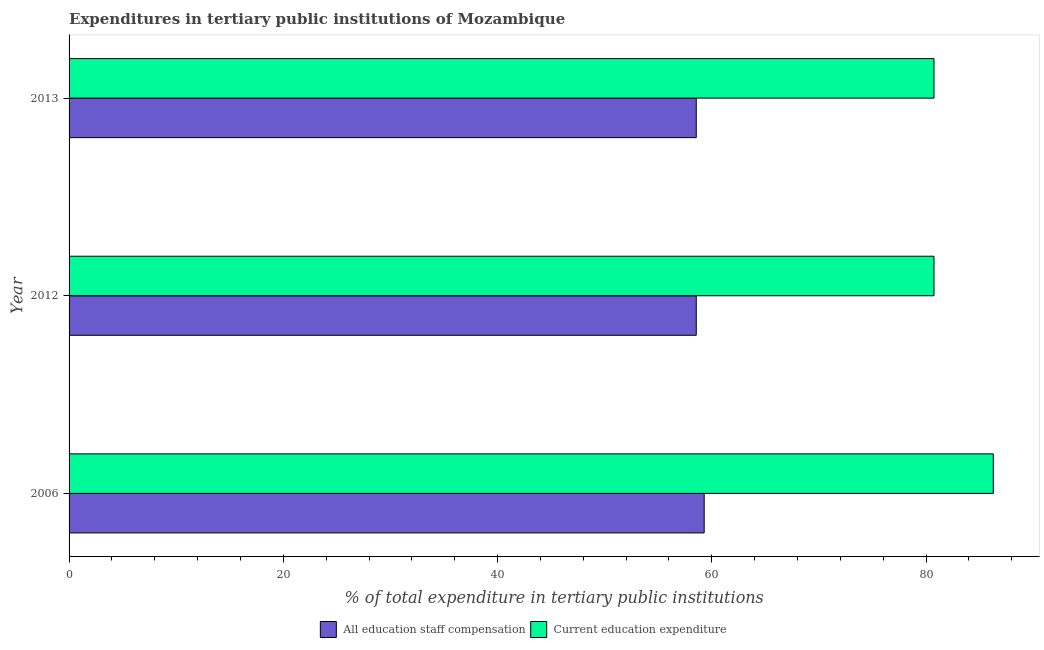How many groups of bars are there?
Your response must be concise. 3. Are the number of bars per tick equal to the number of legend labels?
Your response must be concise. Yes. Are the number of bars on each tick of the Y-axis equal?
Give a very brief answer. Yes. How many bars are there on the 1st tick from the top?
Offer a very short reply. 2. How many bars are there on the 3rd tick from the bottom?
Make the answer very short. 2. What is the expenditure in education in 2013?
Ensure brevity in your answer.  80.74. Across all years, what is the maximum expenditure in education?
Give a very brief answer. 86.28. Across all years, what is the minimum expenditure in education?
Your response must be concise. 80.74. In which year was the expenditure in education minimum?
Offer a very short reply. 2012. What is the total expenditure in education in the graph?
Your answer should be very brief. 247.76. What is the difference between the expenditure in education in 2006 and that in 2012?
Give a very brief answer. 5.53. What is the difference between the expenditure in staff compensation in 2013 and the expenditure in education in 2006?
Offer a very short reply. -27.73. What is the average expenditure in education per year?
Provide a succinct answer. 82.58. In the year 2012, what is the difference between the expenditure in staff compensation and expenditure in education?
Give a very brief answer. -22.19. In how many years, is the expenditure in education greater than 4 %?
Your answer should be compact. 3. What is the difference between the highest and the second highest expenditure in education?
Make the answer very short. 5.53. What is the difference between the highest and the lowest expenditure in education?
Make the answer very short. 5.53. What does the 2nd bar from the top in 2012 represents?
Your answer should be very brief. All education staff compensation. What does the 2nd bar from the bottom in 2012 represents?
Provide a short and direct response. Current education expenditure. How many years are there in the graph?
Provide a succinct answer. 3. Are the values on the major ticks of X-axis written in scientific E-notation?
Provide a succinct answer. No. Does the graph contain any zero values?
Your answer should be very brief. No. Does the graph contain grids?
Offer a terse response. No. Where does the legend appear in the graph?
Your answer should be very brief. Bottom center. How many legend labels are there?
Make the answer very short. 2. How are the legend labels stacked?
Your answer should be compact. Horizontal. What is the title of the graph?
Ensure brevity in your answer.  Expenditures in tertiary public institutions of Mozambique. Does "Underweight" appear as one of the legend labels in the graph?
Provide a succinct answer. No. What is the label or title of the X-axis?
Your answer should be compact. % of total expenditure in tertiary public institutions. What is the label or title of the Y-axis?
Offer a very short reply. Year. What is the % of total expenditure in tertiary public institutions of All education staff compensation in 2006?
Your response must be concise. 59.29. What is the % of total expenditure in tertiary public institutions in Current education expenditure in 2006?
Keep it short and to the point. 86.28. What is the % of total expenditure in tertiary public institutions in All education staff compensation in 2012?
Keep it short and to the point. 58.55. What is the % of total expenditure in tertiary public institutions in Current education expenditure in 2012?
Offer a very short reply. 80.74. What is the % of total expenditure in tertiary public institutions in All education staff compensation in 2013?
Offer a very short reply. 58.55. What is the % of total expenditure in tertiary public institutions in Current education expenditure in 2013?
Offer a terse response. 80.74. Across all years, what is the maximum % of total expenditure in tertiary public institutions of All education staff compensation?
Keep it short and to the point. 59.29. Across all years, what is the maximum % of total expenditure in tertiary public institutions in Current education expenditure?
Your response must be concise. 86.28. Across all years, what is the minimum % of total expenditure in tertiary public institutions of All education staff compensation?
Your answer should be compact. 58.55. Across all years, what is the minimum % of total expenditure in tertiary public institutions of Current education expenditure?
Provide a succinct answer. 80.74. What is the total % of total expenditure in tertiary public institutions in All education staff compensation in the graph?
Give a very brief answer. 176.38. What is the total % of total expenditure in tertiary public institutions of Current education expenditure in the graph?
Your response must be concise. 247.76. What is the difference between the % of total expenditure in tertiary public institutions in All education staff compensation in 2006 and that in 2012?
Offer a very short reply. 0.74. What is the difference between the % of total expenditure in tertiary public institutions in Current education expenditure in 2006 and that in 2012?
Ensure brevity in your answer.  5.53. What is the difference between the % of total expenditure in tertiary public institutions in All education staff compensation in 2006 and that in 2013?
Offer a terse response. 0.74. What is the difference between the % of total expenditure in tertiary public institutions of Current education expenditure in 2006 and that in 2013?
Your answer should be very brief. 5.53. What is the difference between the % of total expenditure in tertiary public institutions in All education staff compensation in 2006 and the % of total expenditure in tertiary public institutions in Current education expenditure in 2012?
Offer a very short reply. -21.45. What is the difference between the % of total expenditure in tertiary public institutions of All education staff compensation in 2006 and the % of total expenditure in tertiary public institutions of Current education expenditure in 2013?
Ensure brevity in your answer.  -21.45. What is the difference between the % of total expenditure in tertiary public institutions in All education staff compensation in 2012 and the % of total expenditure in tertiary public institutions in Current education expenditure in 2013?
Your response must be concise. -22.19. What is the average % of total expenditure in tertiary public institutions in All education staff compensation per year?
Ensure brevity in your answer.  58.79. What is the average % of total expenditure in tertiary public institutions in Current education expenditure per year?
Make the answer very short. 82.59. In the year 2006, what is the difference between the % of total expenditure in tertiary public institutions in All education staff compensation and % of total expenditure in tertiary public institutions in Current education expenditure?
Give a very brief answer. -26.99. In the year 2012, what is the difference between the % of total expenditure in tertiary public institutions in All education staff compensation and % of total expenditure in tertiary public institutions in Current education expenditure?
Keep it short and to the point. -22.19. In the year 2013, what is the difference between the % of total expenditure in tertiary public institutions in All education staff compensation and % of total expenditure in tertiary public institutions in Current education expenditure?
Offer a terse response. -22.19. What is the ratio of the % of total expenditure in tertiary public institutions of All education staff compensation in 2006 to that in 2012?
Keep it short and to the point. 1.01. What is the ratio of the % of total expenditure in tertiary public institutions in Current education expenditure in 2006 to that in 2012?
Provide a succinct answer. 1.07. What is the ratio of the % of total expenditure in tertiary public institutions in All education staff compensation in 2006 to that in 2013?
Your answer should be very brief. 1.01. What is the ratio of the % of total expenditure in tertiary public institutions in Current education expenditure in 2006 to that in 2013?
Provide a short and direct response. 1.07. What is the difference between the highest and the second highest % of total expenditure in tertiary public institutions in All education staff compensation?
Your response must be concise. 0.74. What is the difference between the highest and the second highest % of total expenditure in tertiary public institutions of Current education expenditure?
Provide a short and direct response. 5.53. What is the difference between the highest and the lowest % of total expenditure in tertiary public institutions in All education staff compensation?
Your response must be concise. 0.74. What is the difference between the highest and the lowest % of total expenditure in tertiary public institutions of Current education expenditure?
Ensure brevity in your answer.  5.53. 